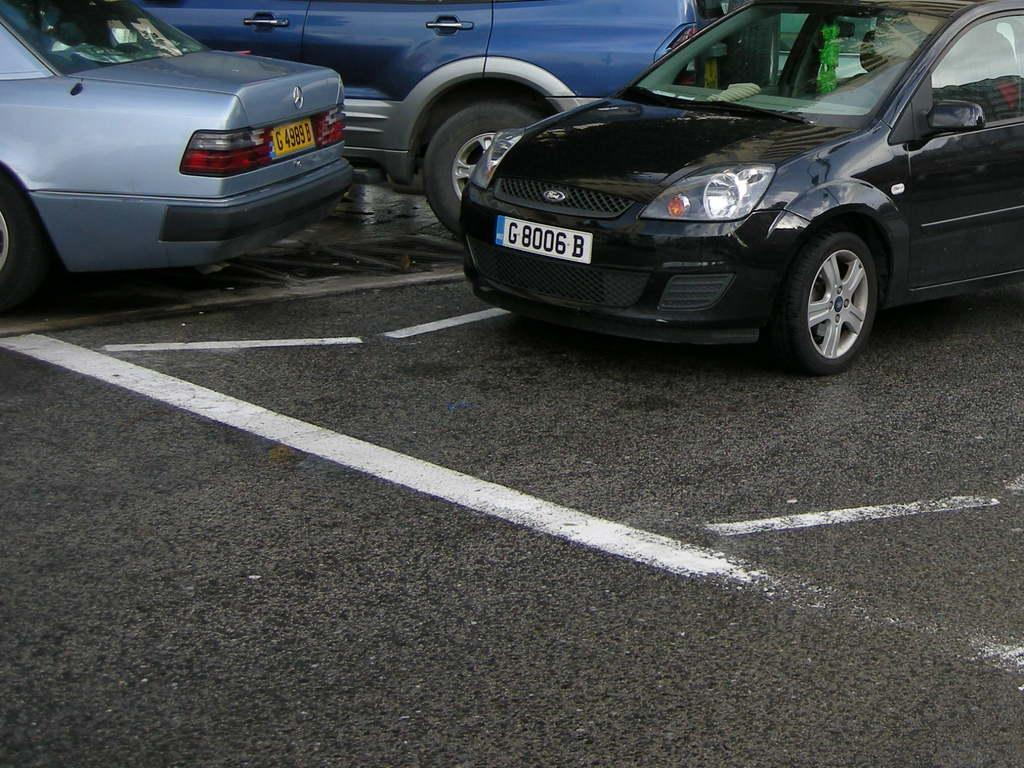What can be seen on the road in the image? There are vehicles on the road in the image. How many women are present with the cats in the image? There are no women or cats present in the image; it only features vehicles on the road. 